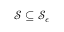<formula> <loc_0><loc_0><loc_500><loc_500>\mathcal { S } \subseteq \mathcal { S } _ { \epsilon }</formula> 